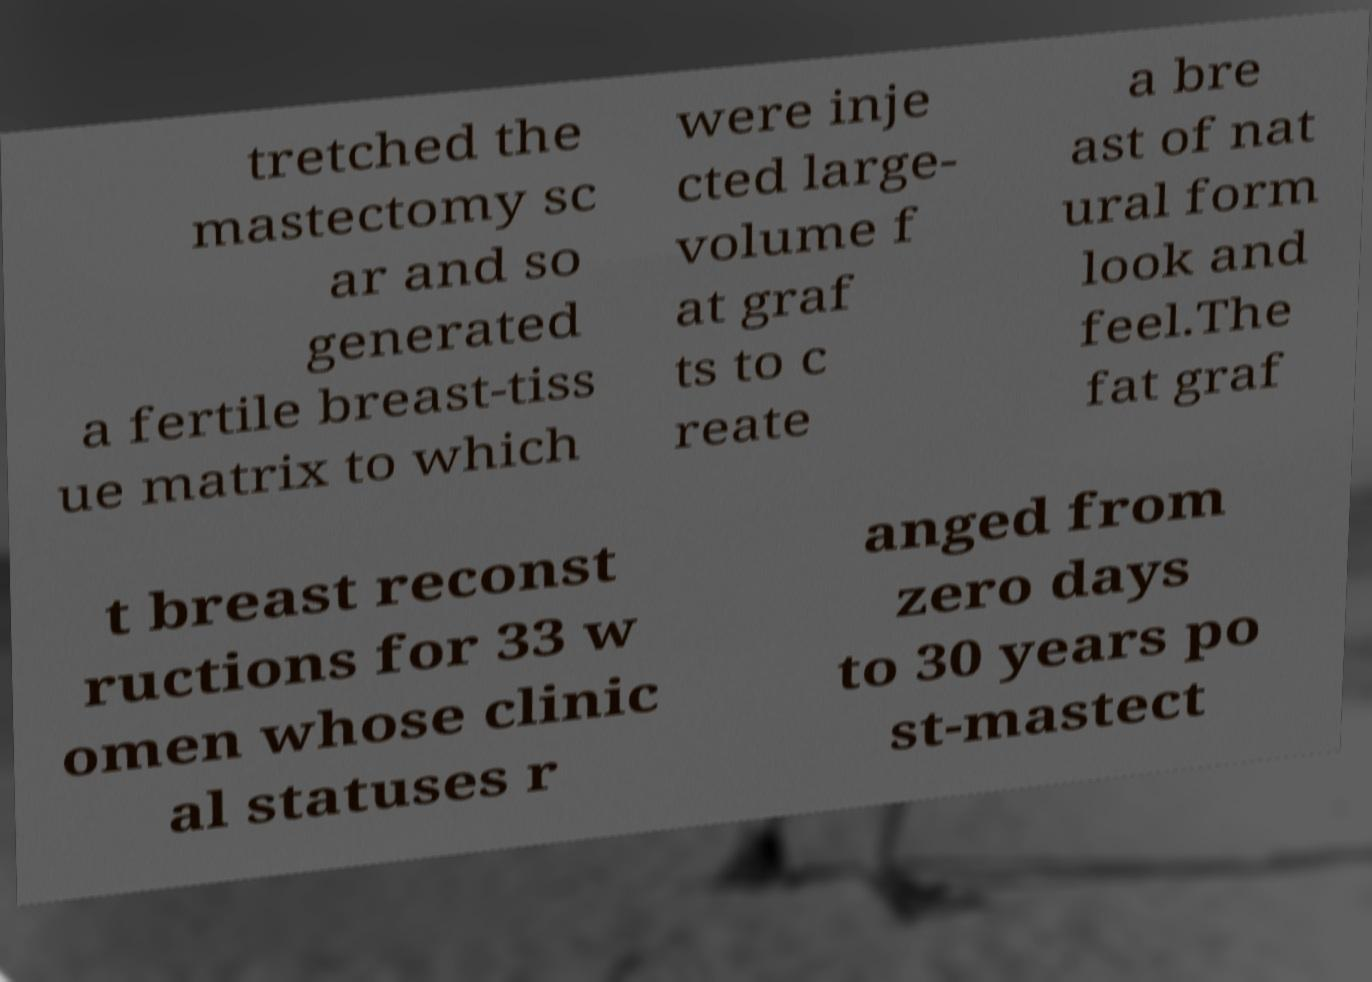Can you accurately transcribe the text from the provided image for me? tretched the mastectomy sc ar and so generated a fertile breast-tiss ue matrix to which were inje cted large- volume f at graf ts to c reate a bre ast of nat ural form look and feel.The fat graf t breast reconst ructions for 33 w omen whose clinic al statuses r anged from zero days to 30 years po st-mastect 